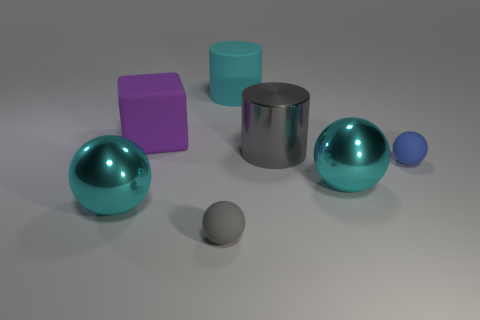Subtract 1 balls. How many balls are left? 3 Add 1 big blue rubber balls. How many objects exist? 8 Subtract all balls. How many objects are left? 3 Add 2 tiny matte things. How many tiny matte things are left? 4 Add 7 blocks. How many blocks exist? 8 Subtract 1 gray spheres. How many objects are left? 6 Subtract all big cyan balls. Subtract all big blocks. How many objects are left? 4 